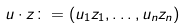Convert formula to latex. <formula><loc_0><loc_0><loc_500><loc_500>u \cdot z \colon = ( u _ { 1 } z _ { 1 } , \dots , u _ { n } z _ { n } )</formula> 